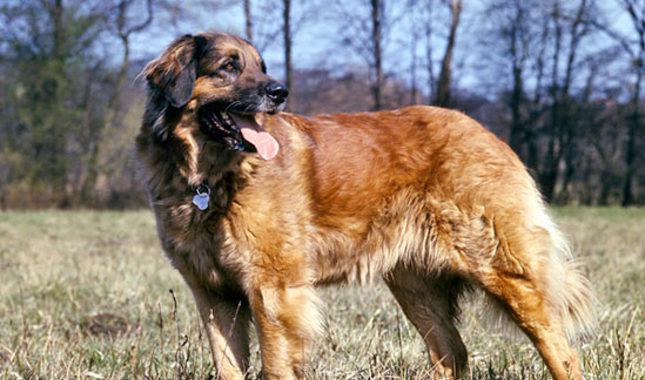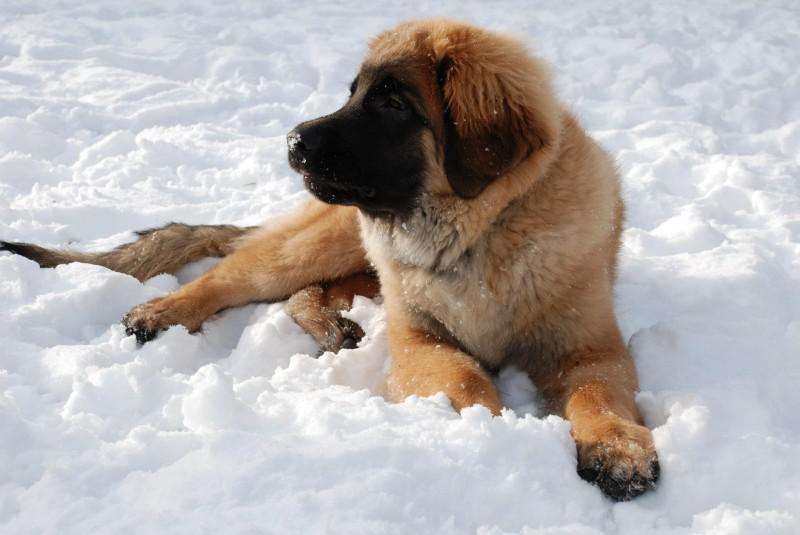The first image is the image on the left, the second image is the image on the right. For the images displayed, is the sentence "One of the images shows a single dog standing in snow." factually correct? Answer yes or no. No. The first image is the image on the left, the second image is the image on the right. Assess this claim about the two images: "No image contains a grassy ground, and at least one image contains a dog standing upright on snow.". Correct or not? Answer yes or no. No. 